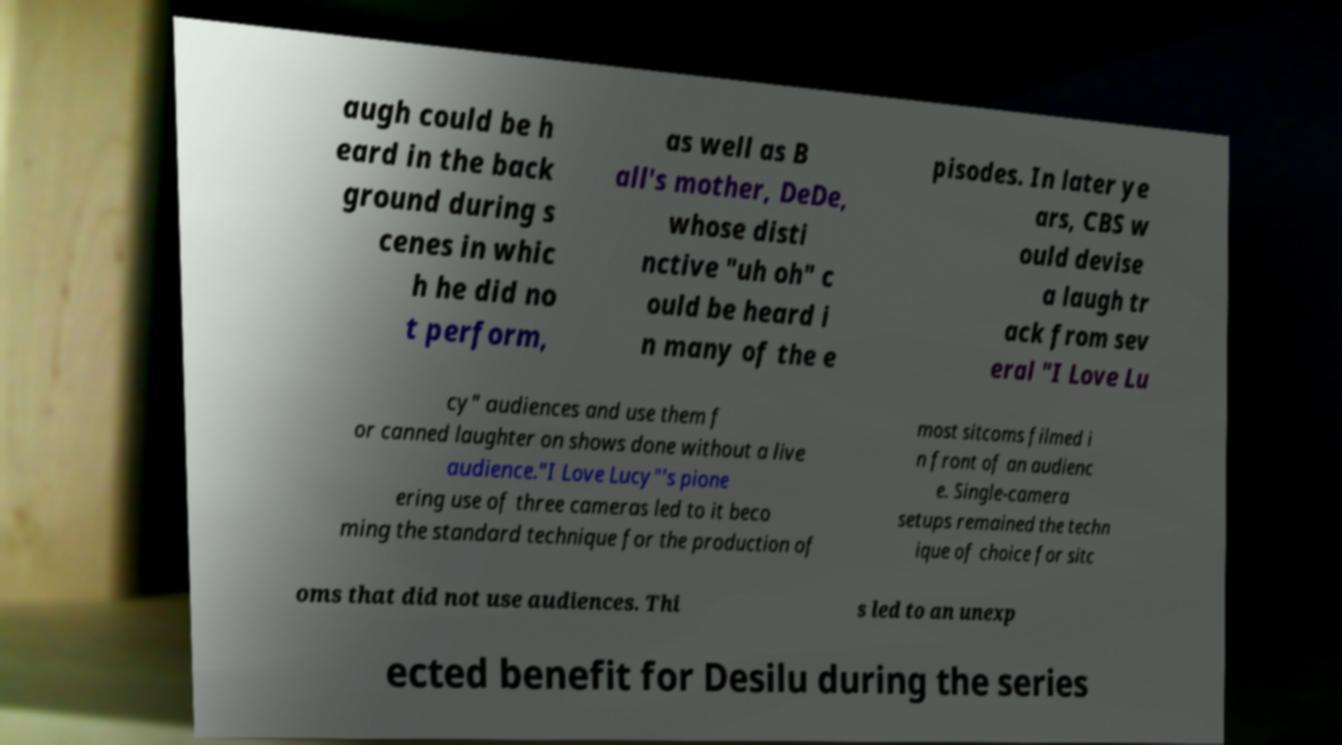Please read and relay the text visible in this image. What does it say? augh could be h eard in the back ground during s cenes in whic h he did no t perform, as well as B all's mother, DeDe, whose disti nctive "uh oh" c ould be heard i n many of the e pisodes. In later ye ars, CBS w ould devise a laugh tr ack from sev eral "I Love Lu cy" audiences and use them f or canned laughter on shows done without a live audience."I Love Lucy"'s pione ering use of three cameras led to it beco ming the standard technique for the production of most sitcoms filmed i n front of an audienc e. Single-camera setups remained the techn ique of choice for sitc oms that did not use audiences. Thi s led to an unexp ected benefit for Desilu during the series 